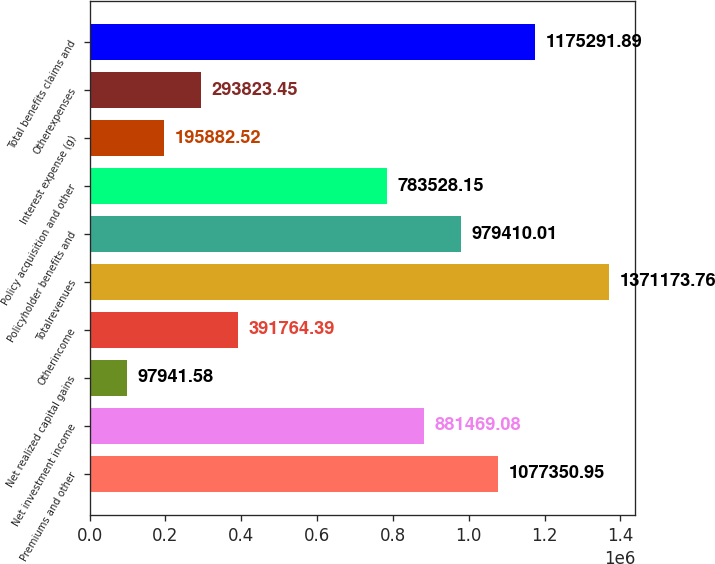Convert chart to OTSL. <chart><loc_0><loc_0><loc_500><loc_500><bar_chart><fcel>Premiums and other<fcel>Net investment income<fcel>Net realized capital gains<fcel>Otherincome<fcel>Totalrevenues<fcel>Policyholder benefits and<fcel>Policy acquisition and other<fcel>Interest expense (g)<fcel>Otherexpenses<fcel>Total benefits claims and<nl><fcel>1.07735e+06<fcel>881469<fcel>97941.6<fcel>391764<fcel>1.37117e+06<fcel>979410<fcel>783528<fcel>195883<fcel>293823<fcel>1.17529e+06<nl></chart> 